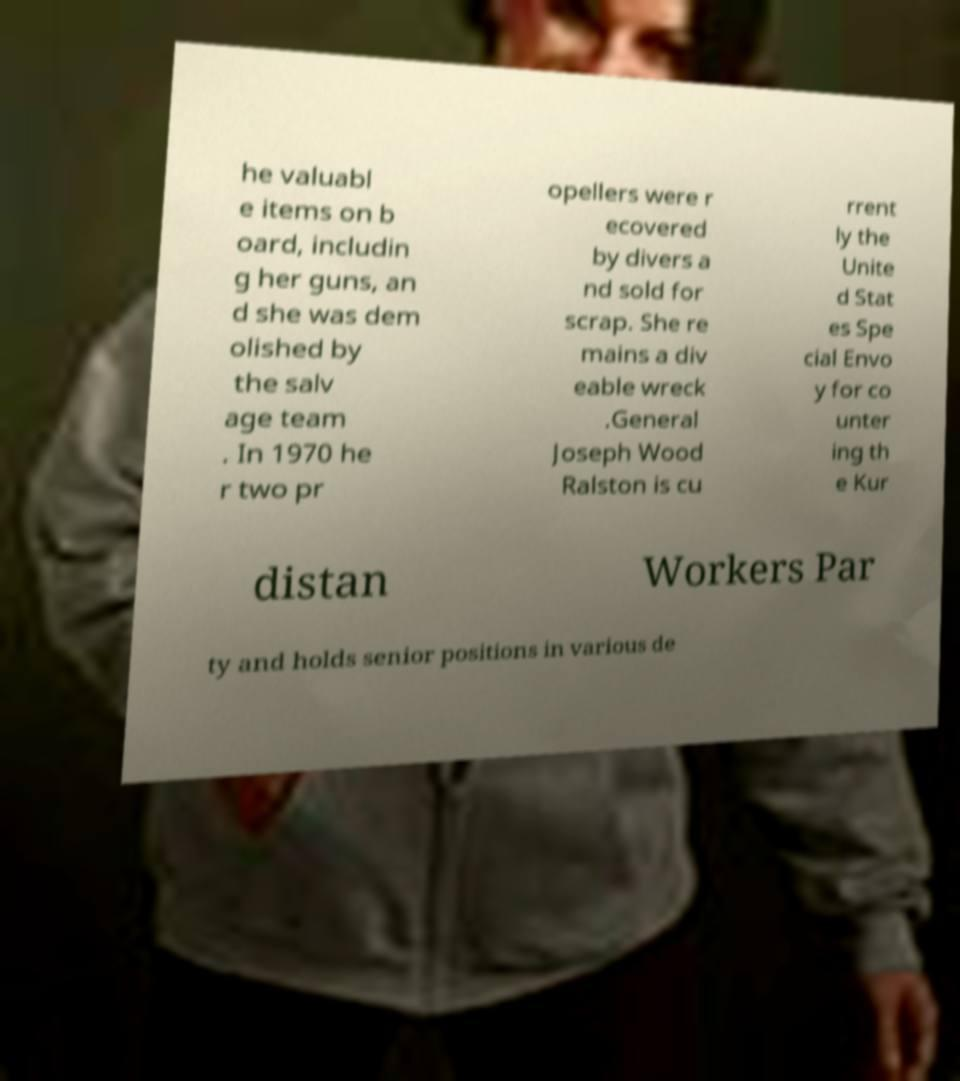Can you accurately transcribe the text from the provided image for me? he valuabl e items on b oard, includin g her guns, an d she was dem olished by the salv age team . In 1970 he r two pr opellers were r ecovered by divers a nd sold for scrap. She re mains a div eable wreck .General Joseph Wood Ralston is cu rrent ly the Unite d Stat es Spe cial Envo y for co unter ing th e Kur distan Workers Par ty and holds senior positions in various de 